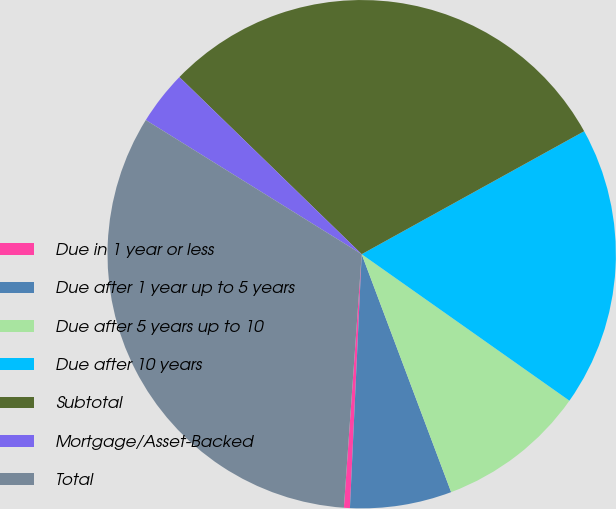<chart> <loc_0><loc_0><loc_500><loc_500><pie_chart><fcel>Due in 1 year or less<fcel>Due after 1 year up to 5 years<fcel>Due after 5 years up to 10<fcel>Due after 10 years<fcel>Subtotal<fcel>Mortgage/Asset-Backed<fcel>Total<nl><fcel>0.38%<fcel>6.46%<fcel>9.5%<fcel>17.81%<fcel>29.69%<fcel>3.42%<fcel>32.73%<nl></chart> 